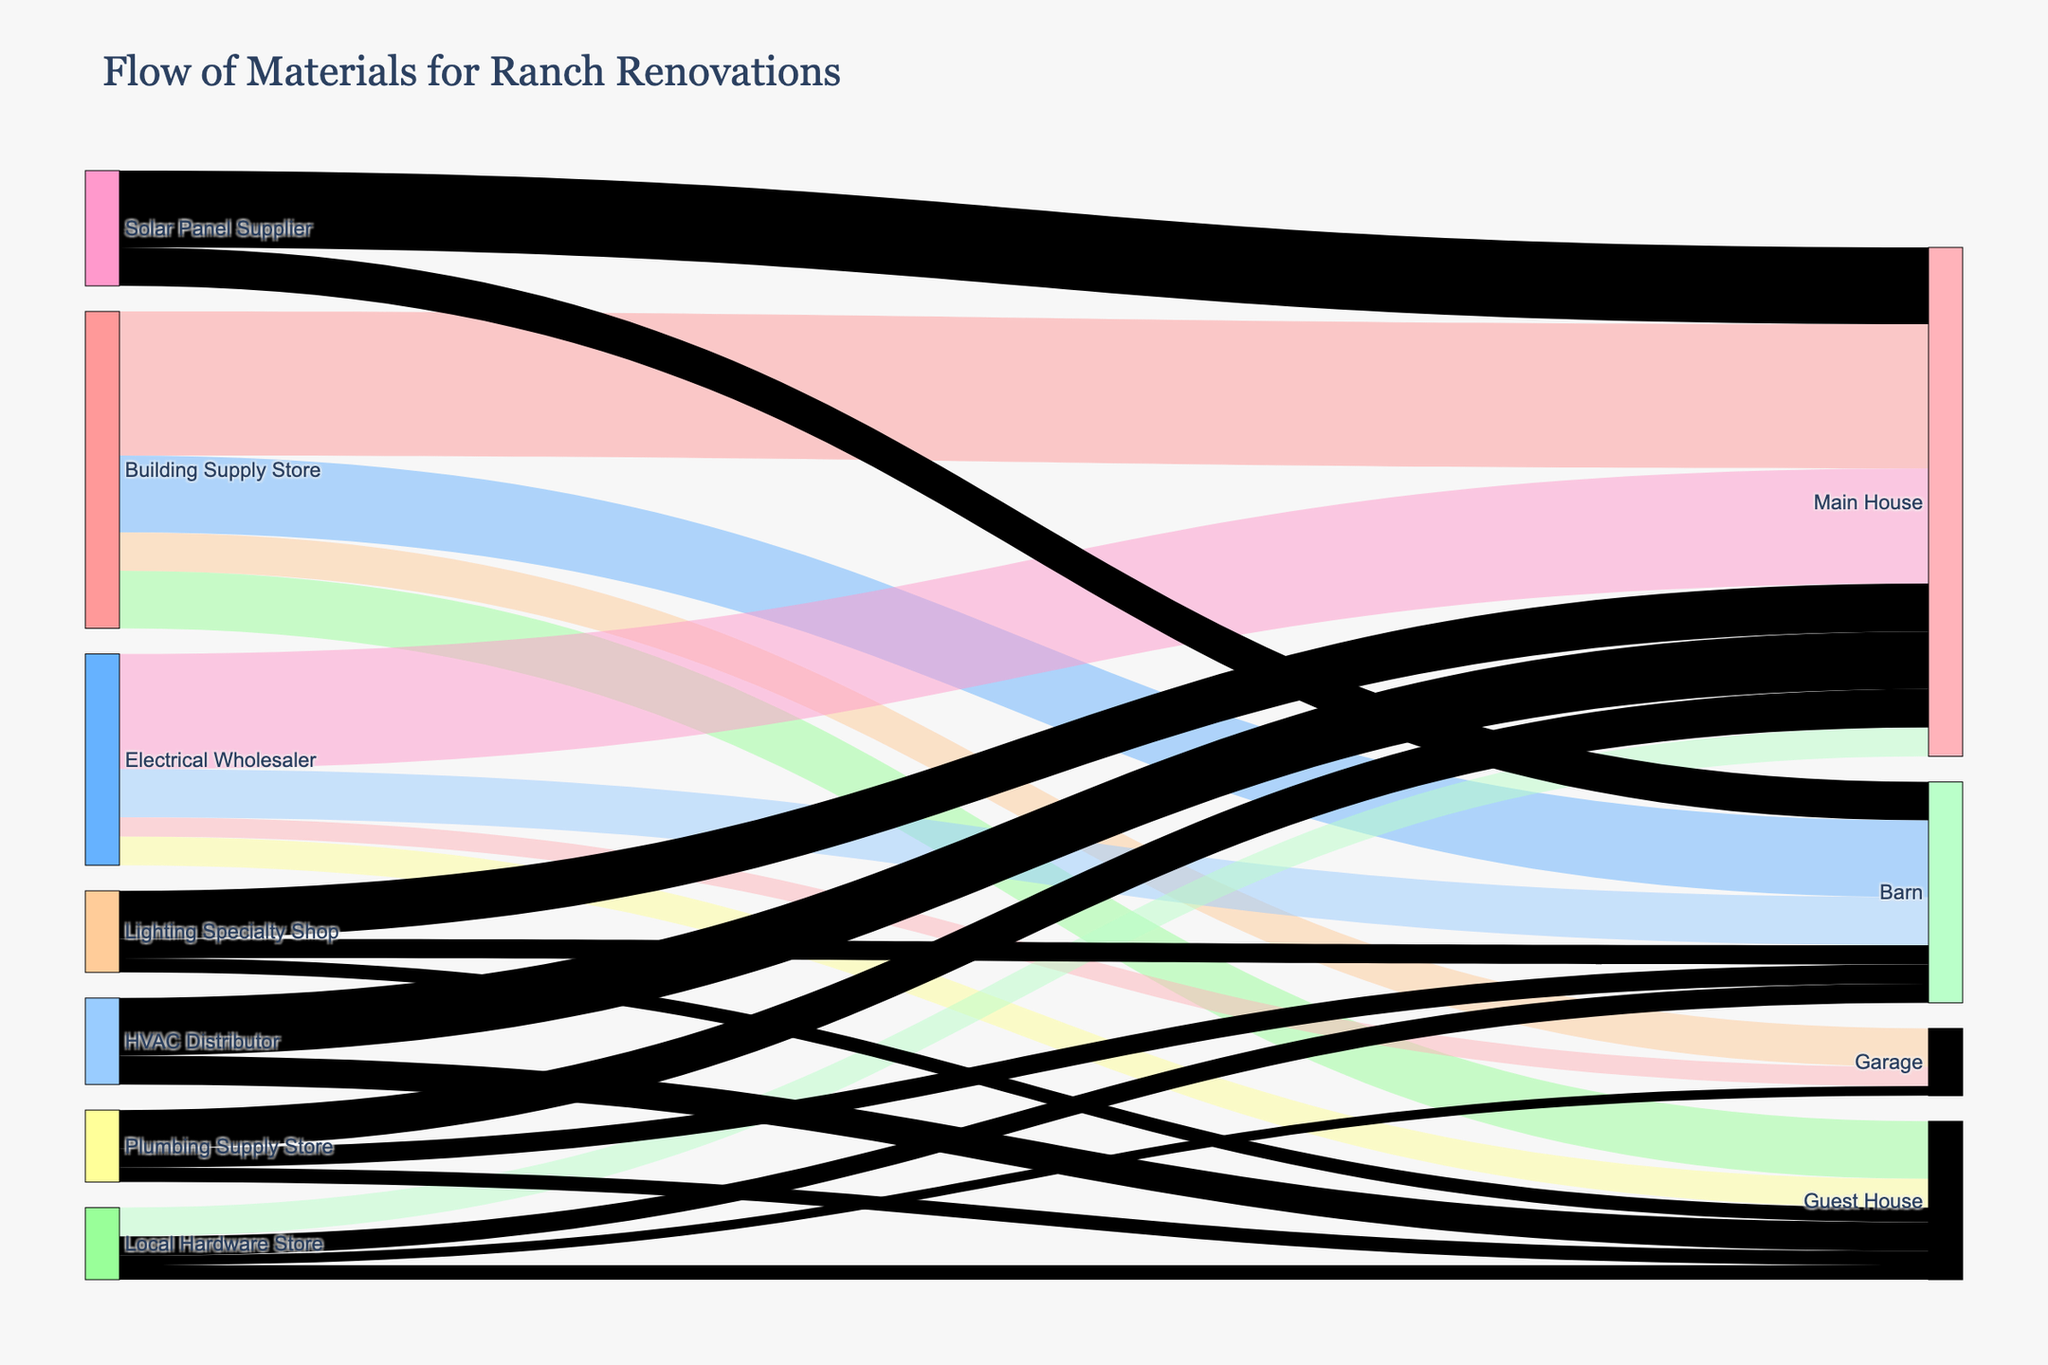What is the total value of materials flowing to the Main House? To find the total value, sum the values from all sources to the Main House. These are 15000 from the Building Supply Store, 12000 from the Electrical Wholesaler, 3000 from the Local Hardware Store, 5000 from the Lighting Specialty Shop, 8000 from the Solar Panel Supplier, 6000 from the HVAC Distributor, and 4000 from the Plumbing Supply Store. Therefore, 15000 + 12000 + 3000 + 5000 + 8000 + 6000 + 4000 = 53000.
Answer: 53000 Which area of the property receives the least amount of materials from the Local Hardware Store? Check the values for each area supplied by the Local Hardware Store: Main House receives 3000, Barn receives 2000, Guest House receives 1500, and Garage receives 1000. The smallest value is 1000, which goes to the Garage.
Answer: Garage Which supplier provides the most materials to the Barn? Compare the material values from each supplier to the Barn: Building Supply Store provides 8000, Electrical Wholesaler 5000, Local Hardware Store 2000, Lighting Specialty Shop 2000, Solar Panel Supplier 4000, and Plumbing Supply Store 2000. The maximum value is 8000 from the Building Supply Store.
Answer: Building Supply Store What is the total value of materials flowing into the Guest House from all suppliers? Add up all the values directed to the Guest House: 6000 from the Building Supply Store, 3000 from the Electrical Wholesaler, 1500 from the Local Hardware Store, 1500 from the Lighting Specialty Shop, 3000 from the HVAC Distributor, and 1500 from the Plumbing Supply Store. Therefore, 6000 + 3000 + 1500 + 1500 + 3000 + 1500 = 16500.
Answer: 16500 Is the amount of materials from the Solar Panel Supplier to the Main House greater than from the Lighting Specialty Shop to the Main House? Compare the values from the Solar Panel Supplier and Lighting Specialty Shop to the Main House: Solar Panel Supplier provides 8000 and Lighting Specialty Shop provides 5000. Since 8000 > 5000, the Solar Panel Supplier provides more.
Answer: Yes Which property area is receiving more materials: Garage or Guest House? Sum up the values going to the Garage and Guest House. Garage receives 4000 from Building Supply Store, 2000 from Electrical Wholesaler, 1000 from Local Hardware Store which totals to 7000. Guest House receives 6000 from Building Supply Store, 3000 from Electrical Wholesaler, 1500 from Local Hardware Store, 1500 from Lighting Specialty Shop, and 3000 from HVAC Distributor, 1500 from Plumbing Supply Store which totals to 16500. Since 16500 > 7000, Guest House receives more.
Answer: Guest House What is the total contribution of the Electrical Wholesaler to the property renovations? Add up all the values provided by the Electrical Wholesaler: 12000 to Main House, 5000 to Barn, 3000 to Guest House, 2000 to Garage, which sums up to 12000 + 5000 + 3000 + 2000 = 22000.
Answer: 22000 Which supplier provides materials to the most property areas? Determine the number of property areas each supplier supplies to: Building Supply Store (Main House, Barn, Guest House, Garage = 4 areas), Electrical Wholesaler (Main House, Barn, Guest House, Garage = 4 areas), Local Hardware Store (Main House, Barn, Guest House, Garage = 4 areas), Lighting Specialty Shop (Main House, Barn, Guest House = 3 areas), Solar Panel Supplier (Main House, Barn = 2 areas), HVAC Distributor (Main House, Guest House = 2 areas), Plumbing Supply Store (Main House, Barn, Guest House = 3 areas). The maximum number is 4, thus Building Supply Store, Electrical Wholesaler, and Local Hardware Store each supply to the most areas.
Answer: Building Supply Store, Electrical Wholesaler, Local Hardware Store 